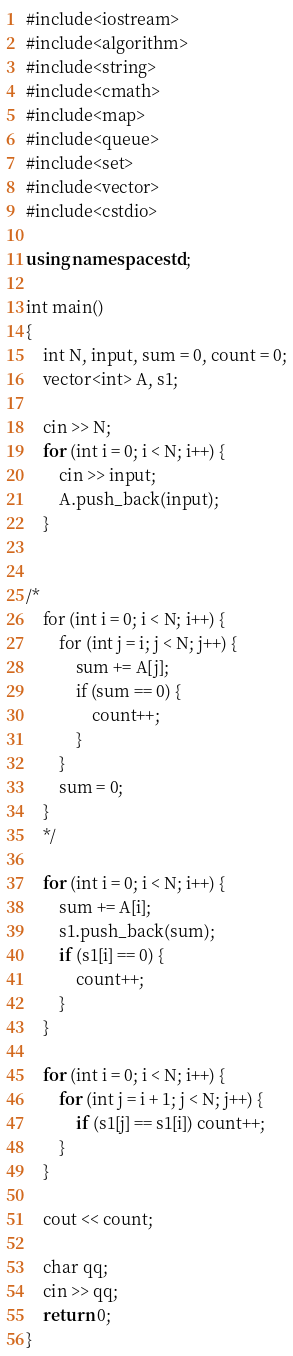<code> <loc_0><loc_0><loc_500><loc_500><_C++_>#include<iostream>
#include<algorithm>
#include<string>
#include<cmath>
#include<map>
#include<queue>
#include<set>
#include<vector>
#include<cstdio>

using namespace std;

int main()
{
	int N, input, sum = 0, count = 0;
	vector<int> A, s1;

	cin >> N;
	for (int i = 0; i < N; i++) {
		cin >> input;
		A.push_back(input);
	}


/*
	for (int i = 0; i < N; i++) {
		for (int j = i; j < N; j++) {
			sum += A[j];
			if (sum == 0) {
				count++;
			}
		}
		sum = 0;
	}
	*/

	for (int i = 0; i < N; i++) {
		sum += A[i];
		s1.push_back(sum);
		if (s1[i] == 0) {
			count++;
		}
	}

	for (int i = 0; i < N; i++) {
		for (int j = i + 1; j < N; j++) {
			if (s1[j] == s1[i]) count++;
		}
	}

	cout << count;

	char qq;
	cin >> qq;
	return 0;
}</code> 